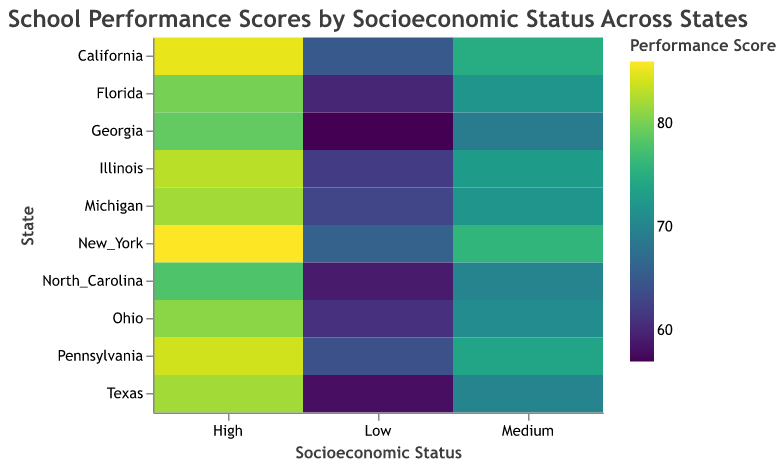What is the highest performance score for low socioeconomic status (Low_SES) across all states? Look at the "Low" column in the heatmap. The highest value in the "Low" column corresponds to New York, with a score of 66.
Answer: 66 Which state has the smallest difference in performance scores between low and high socioeconomic statuses? For each state, calculate the difference between the high SES and low SES performance scores. The smallest difference is 20, observed in New York (86 - 66 = 20).
Answer: New York What is the average performance score of high socioeconomic status (High_SES) across all states? To find the average, sum the performance scores of the "High" category for all states and divide by the number of states. (85 + 82 + 86 + 80 + 83 + 84 + 81 + 79 + 78 + 82) / 10 = 83.
Answer: 83 Which state shows the most significant performance gap between low and medium socioeconomic statuses? Calculate the difference between the medium and low SES performance scores for each state. The largest gap is 13, observed in Georgia (69 - 57 = 12).
Answer: Georgia How do the performance scores of California compare across different socioeconomic statuses? Examine the rectangle's color in the California row, focusing on the Low, Medium, and High columns. The scores are: Low SES = 65, Medium SES = 75, High SES = 85.
Answer: 65, 75, 85 What is the most common color present in the heatmap? By observing the colors, the most prevalent color corresponds to performance scores in the range of 70–75.
Answer: 70-75 range Which state shows the highest overall performance score? Look at the High SES column for the highest value, New York, which has a score of 86.
Answer: New York How many states have a medium SES performance score higher than 73? Count the number of states where the Medium SES performance score is greater than 73. Illinois, New York, Pennsylvania, and California fall into this category.
Answer: 4 states 